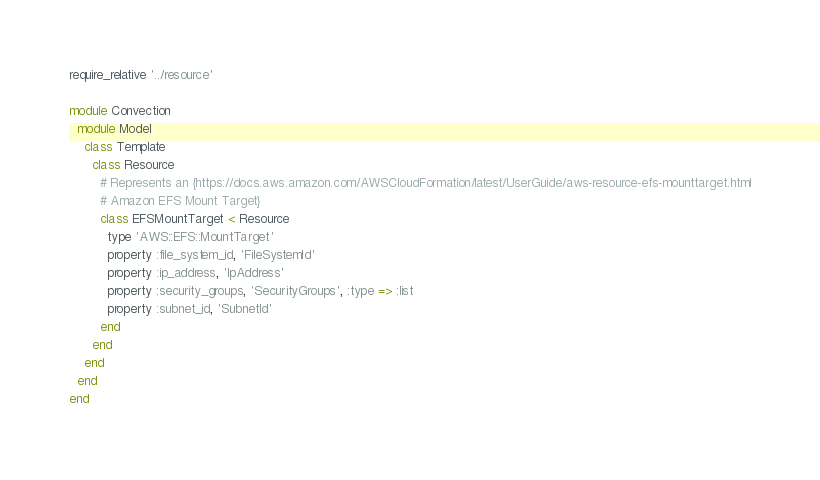<code> <loc_0><loc_0><loc_500><loc_500><_Ruby_>require_relative '../resource'

module Convection
  module Model
    class Template
      class Resource
        # Represents an {https://docs.aws.amazon.com/AWSCloudFormation/latest/UserGuide/aws-resource-efs-mounttarget.html
        # Amazon EFS Mount Target}
        class EFSMountTarget < Resource
          type 'AWS::EFS::MountTarget'
          property :file_system_id, 'FileSystemId'
          property :ip_address, 'IpAddress'
          property :security_groups, 'SecurityGroups', :type => :list
          property :subnet_id, 'SubnetId'
        end
      end
    end
  end
end
</code> 